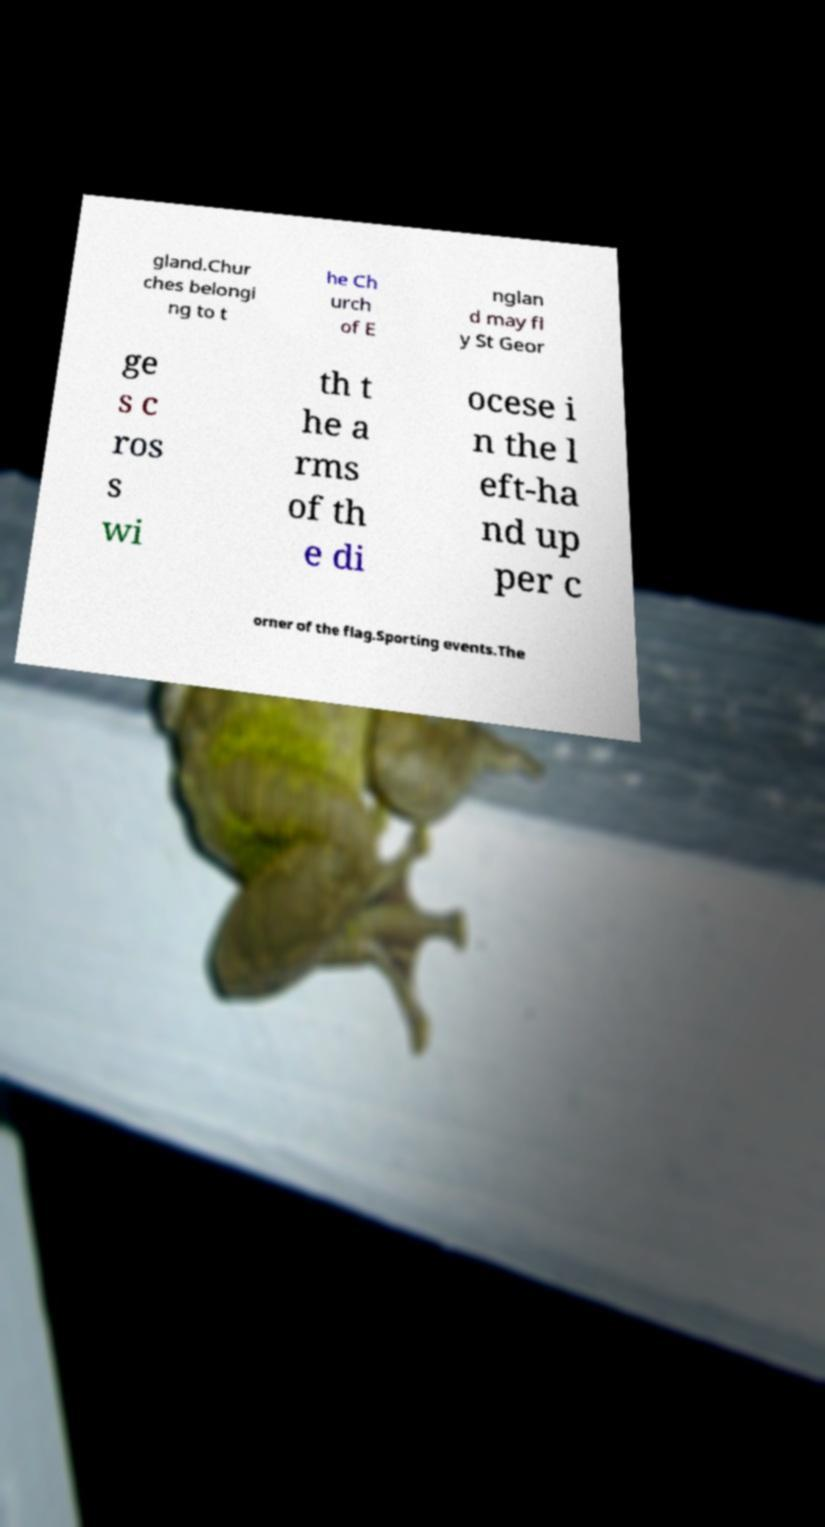I need the written content from this picture converted into text. Can you do that? gland.Chur ches belongi ng to t he Ch urch of E nglan d may fl y St Geor ge s c ros s wi th t he a rms of th e di ocese i n the l eft-ha nd up per c orner of the flag.Sporting events.The 